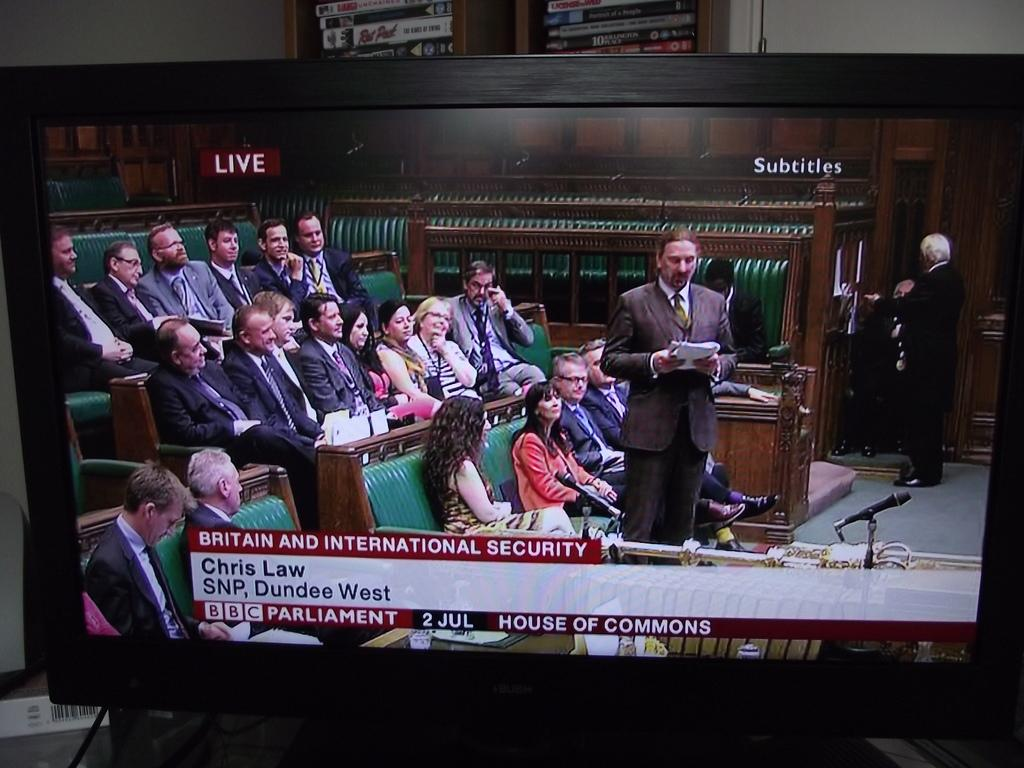<image>
Describe the image concisely. A tv is tuned into a BBC Parliament discussion on security. 